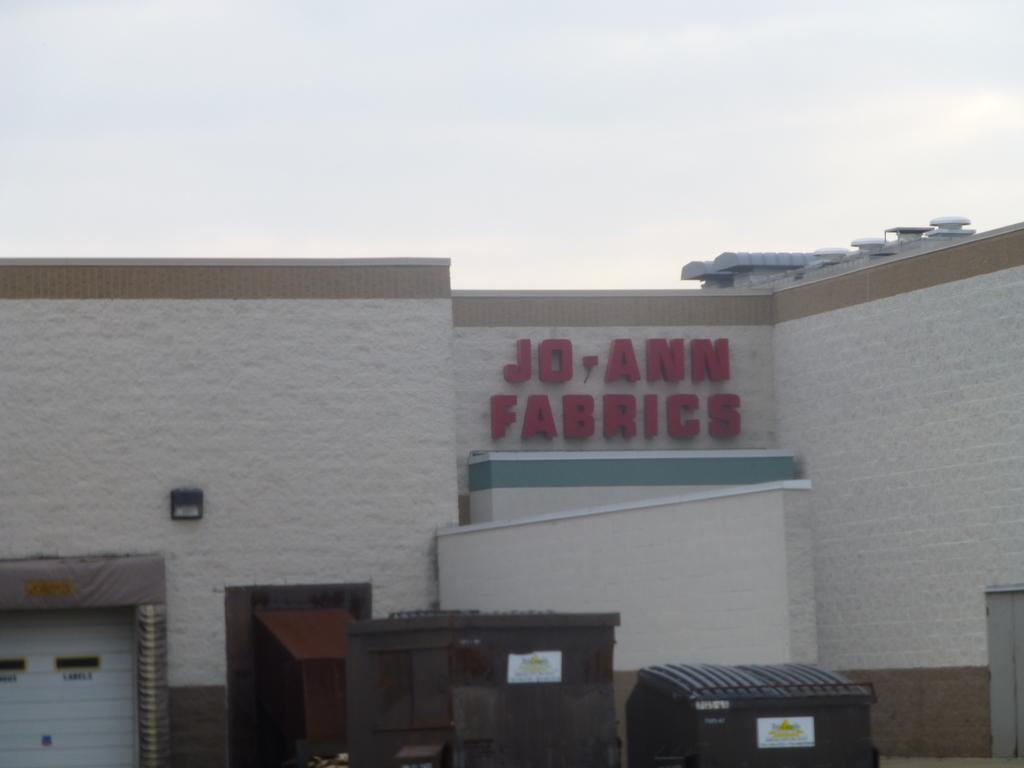What is the main subject of the image? The main subject of the image is a building. Can you describe any specific features on the building? There is a name written in red color on the wall of the building. What can be seen in the background of the image? The sky is visible at the top of the image. What type of work is being done on the spot in the image? There is no indication of any work being done in the image; it only shows a building with a name written on the wall and the sky in the background. 